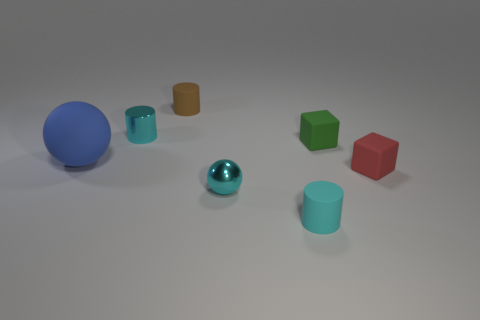What shape is the cyan thing behind the thing that is left of the small cyan object behind the large matte object?
Give a very brief answer. Cylinder. Are there more brown cylinders in front of the small cyan rubber cylinder than tiny red metallic cylinders?
Ensure brevity in your answer.  No. Is the shape of the red matte object that is in front of the small green block the same as  the cyan matte object?
Your answer should be very brief. No. There is a ball that is to the right of the brown cylinder; what material is it?
Offer a terse response. Metal. How many green things have the same shape as the small brown matte thing?
Your answer should be very brief. 0. What is the material of the small cyan object that is behind the small matte cube that is on the left side of the red matte block?
Provide a succinct answer. Metal. The shiny object that is the same color as the metallic cylinder is what shape?
Ensure brevity in your answer.  Sphere. Are there any small cyan cylinders made of the same material as the large sphere?
Give a very brief answer. Yes. The brown rubber thing has what shape?
Provide a short and direct response. Cylinder. What number of blue balls are there?
Your response must be concise. 1. 